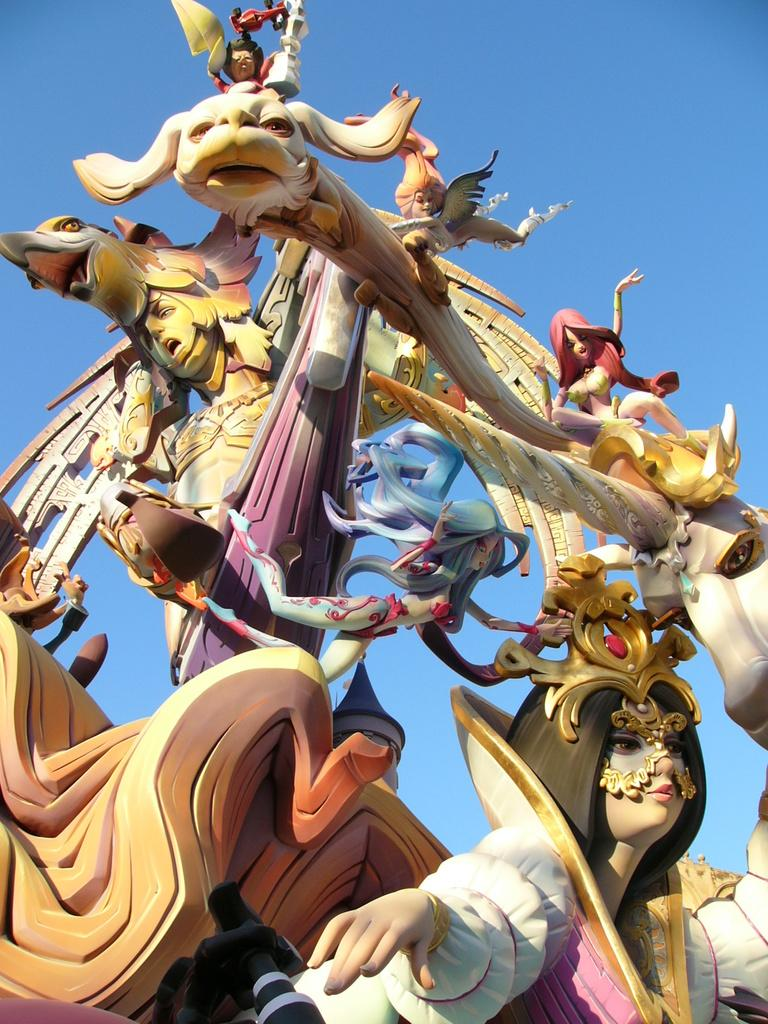What type of art is present in the image? There are sculptures in the image. What is visible in the background of the image? The sky is visible behind the sculptures in the image. Can you tell me how many birds are in the flock flying over the sculptures in the image? There is no flock of birds present in the image; it only features sculptures and the sky. What role does the father play in the image? There is no reference to a father or any human figures in the image, as it only features sculptures and the sky. 